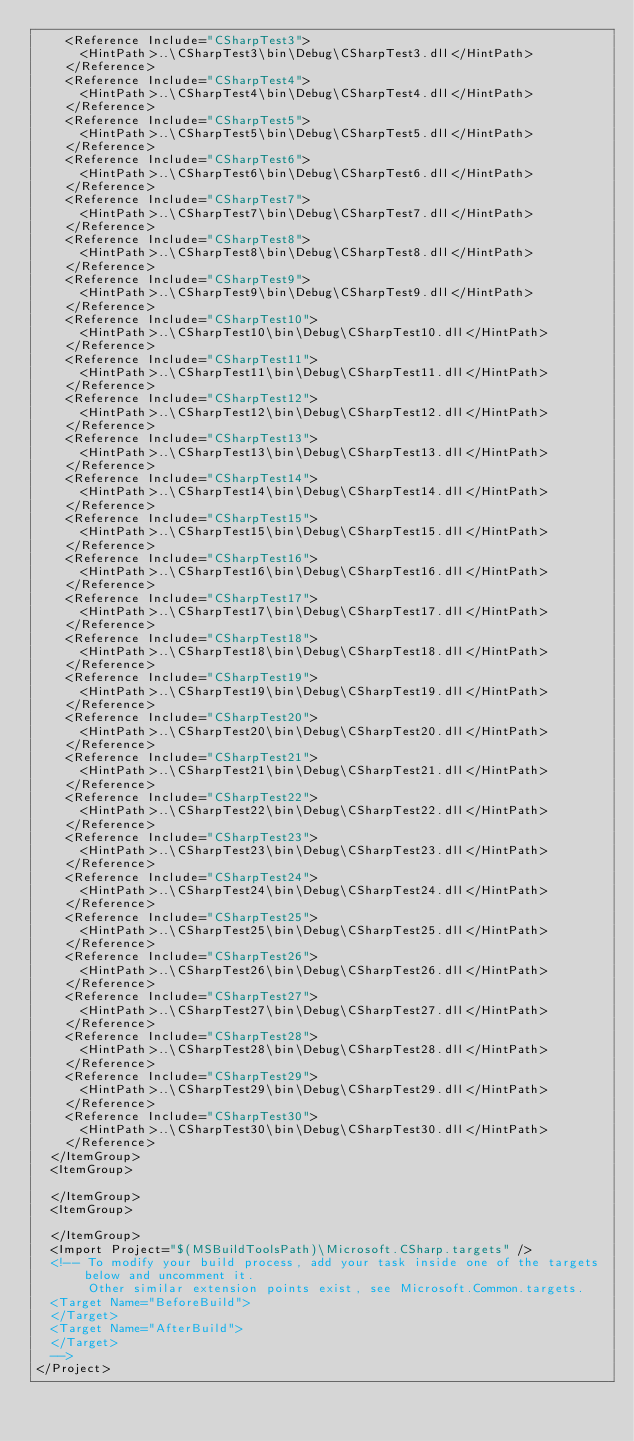Convert code to text. <code><loc_0><loc_0><loc_500><loc_500><_XML_>    <Reference Include="CSharpTest3">
      <HintPath>..\CSharpTest3\bin\Debug\CSharpTest3.dll</HintPath>
    </Reference>
    <Reference Include="CSharpTest4">
      <HintPath>..\CSharpTest4\bin\Debug\CSharpTest4.dll</HintPath>
    </Reference>
    <Reference Include="CSharpTest5">
      <HintPath>..\CSharpTest5\bin\Debug\CSharpTest5.dll</HintPath>
    </Reference>
    <Reference Include="CSharpTest6">
      <HintPath>..\CSharpTest6\bin\Debug\CSharpTest6.dll</HintPath>
    </Reference>
    <Reference Include="CSharpTest7">
      <HintPath>..\CSharpTest7\bin\Debug\CSharpTest7.dll</HintPath>
    </Reference>
    <Reference Include="CSharpTest8">
      <HintPath>..\CSharpTest8\bin\Debug\CSharpTest8.dll</HintPath>
    </Reference>
    <Reference Include="CSharpTest9">
      <HintPath>..\CSharpTest9\bin\Debug\CSharpTest9.dll</HintPath>
    </Reference>
    <Reference Include="CSharpTest10">
      <HintPath>..\CSharpTest10\bin\Debug\CSharpTest10.dll</HintPath>
    </Reference>
    <Reference Include="CSharpTest11">
      <HintPath>..\CSharpTest11\bin\Debug\CSharpTest11.dll</HintPath>
    </Reference>
    <Reference Include="CSharpTest12">
      <HintPath>..\CSharpTest12\bin\Debug\CSharpTest12.dll</HintPath>
    </Reference>
    <Reference Include="CSharpTest13">
      <HintPath>..\CSharpTest13\bin\Debug\CSharpTest13.dll</HintPath>
    </Reference>
    <Reference Include="CSharpTest14">
      <HintPath>..\CSharpTest14\bin\Debug\CSharpTest14.dll</HintPath>
    </Reference>
    <Reference Include="CSharpTest15">
      <HintPath>..\CSharpTest15\bin\Debug\CSharpTest15.dll</HintPath>
    </Reference>
    <Reference Include="CSharpTest16">
      <HintPath>..\CSharpTest16\bin\Debug\CSharpTest16.dll</HintPath>
    </Reference>
    <Reference Include="CSharpTest17">
      <HintPath>..\CSharpTest17\bin\Debug\CSharpTest17.dll</HintPath>
    </Reference>
    <Reference Include="CSharpTest18">
      <HintPath>..\CSharpTest18\bin\Debug\CSharpTest18.dll</HintPath>
    </Reference>
    <Reference Include="CSharpTest19">
      <HintPath>..\CSharpTest19\bin\Debug\CSharpTest19.dll</HintPath>
    </Reference>
    <Reference Include="CSharpTest20">
      <HintPath>..\CSharpTest20\bin\Debug\CSharpTest20.dll</HintPath>
    </Reference>
    <Reference Include="CSharpTest21">
      <HintPath>..\CSharpTest21\bin\Debug\CSharpTest21.dll</HintPath>
    </Reference>
    <Reference Include="CSharpTest22">
      <HintPath>..\CSharpTest22\bin\Debug\CSharpTest22.dll</HintPath>
    </Reference>
    <Reference Include="CSharpTest23">
      <HintPath>..\CSharpTest23\bin\Debug\CSharpTest23.dll</HintPath>
    </Reference>
    <Reference Include="CSharpTest24">
      <HintPath>..\CSharpTest24\bin\Debug\CSharpTest24.dll</HintPath>
    </Reference>
    <Reference Include="CSharpTest25">
      <HintPath>..\CSharpTest25\bin\Debug\CSharpTest25.dll</HintPath>
    </Reference>
    <Reference Include="CSharpTest26">
      <HintPath>..\CSharpTest26\bin\Debug\CSharpTest26.dll</HintPath>
    </Reference>
    <Reference Include="CSharpTest27">
      <HintPath>..\CSharpTest27\bin\Debug\CSharpTest27.dll</HintPath>
    </Reference>
    <Reference Include="CSharpTest28">
      <HintPath>..\CSharpTest28\bin\Debug\CSharpTest28.dll</HintPath>
    </Reference>
    <Reference Include="CSharpTest29">
      <HintPath>..\CSharpTest29\bin\Debug\CSharpTest29.dll</HintPath>
    </Reference>
    <Reference Include="CSharpTest30">
      <HintPath>..\CSharpTest30\bin\Debug\CSharpTest30.dll</HintPath>
    </Reference>
  </ItemGroup>
  <ItemGroup>

  </ItemGroup>
  <ItemGroup>

  </ItemGroup>
  <Import Project="$(MSBuildToolsPath)\Microsoft.CSharp.targets" />
  <!-- To modify your build process, add your task inside one of the targets below and uncomment it. 
       Other similar extension points exist, see Microsoft.Common.targets.
  <Target Name="BeforeBuild">
  </Target>
  <Target Name="AfterBuild">
  </Target>
  -->
</Project></code> 